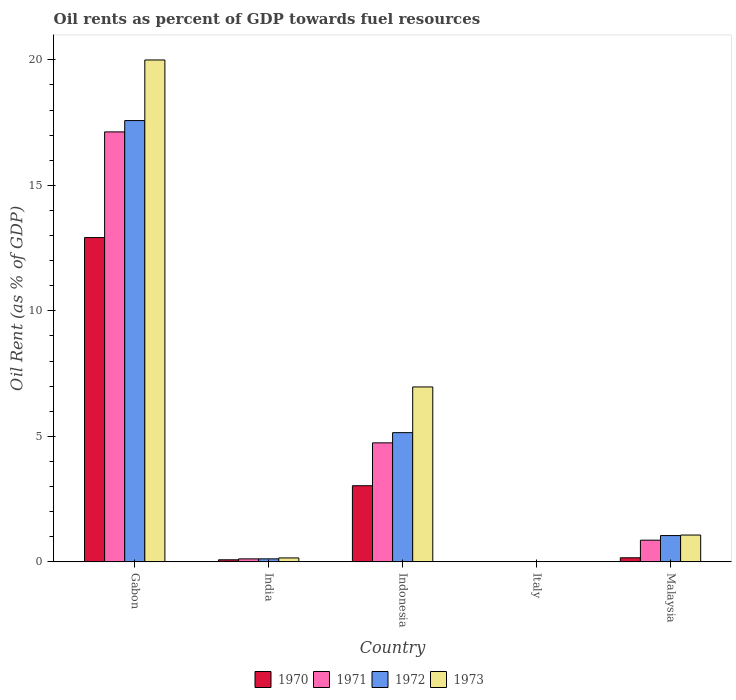How many groups of bars are there?
Give a very brief answer. 5. What is the label of the 5th group of bars from the left?
Ensure brevity in your answer.  Malaysia. What is the oil rent in 1970 in Gabon?
Keep it short and to the point. 12.92. Across all countries, what is the maximum oil rent in 1972?
Offer a very short reply. 17.58. Across all countries, what is the minimum oil rent in 1970?
Give a very brief answer. 0.01. In which country was the oil rent in 1971 maximum?
Your answer should be compact. Gabon. In which country was the oil rent in 1970 minimum?
Your answer should be compact. Italy. What is the total oil rent in 1970 in the graph?
Your answer should be compact. 16.21. What is the difference between the oil rent in 1970 in India and that in Italy?
Your answer should be very brief. 0.07. What is the difference between the oil rent in 1971 in Indonesia and the oil rent in 1970 in Gabon?
Ensure brevity in your answer.  -8.18. What is the average oil rent in 1970 per country?
Provide a short and direct response. 3.24. What is the difference between the oil rent of/in 1973 and oil rent of/in 1971 in India?
Give a very brief answer. 0.04. What is the ratio of the oil rent in 1970 in Gabon to that in Italy?
Your answer should be compact. 1310.76. What is the difference between the highest and the second highest oil rent in 1972?
Your answer should be very brief. 12.43. What is the difference between the highest and the lowest oil rent in 1970?
Make the answer very short. 12.91. In how many countries, is the oil rent in 1973 greater than the average oil rent in 1973 taken over all countries?
Give a very brief answer. 2. Is the sum of the oil rent in 1970 in Gabon and Malaysia greater than the maximum oil rent in 1973 across all countries?
Offer a very short reply. No. How many countries are there in the graph?
Your answer should be compact. 5. What is the difference between two consecutive major ticks on the Y-axis?
Your response must be concise. 5. Are the values on the major ticks of Y-axis written in scientific E-notation?
Your response must be concise. No. Where does the legend appear in the graph?
Make the answer very short. Bottom center. What is the title of the graph?
Provide a succinct answer. Oil rents as percent of GDP towards fuel resources. Does "2004" appear as one of the legend labels in the graph?
Your answer should be compact. No. What is the label or title of the X-axis?
Your answer should be compact. Country. What is the label or title of the Y-axis?
Provide a succinct answer. Oil Rent (as % of GDP). What is the Oil Rent (as % of GDP) in 1970 in Gabon?
Ensure brevity in your answer.  12.92. What is the Oil Rent (as % of GDP) of 1971 in Gabon?
Your answer should be very brief. 17.13. What is the Oil Rent (as % of GDP) of 1972 in Gabon?
Provide a succinct answer. 17.58. What is the Oil Rent (as % of GDP) of 1973 in Gabon?
Provide a short and direct response. 19.99. What is the Oil Rent (as % of GDP) of 1970 in India?
Provide a succinct answer. 0.08. What is the Oil Rent (as % of GDP) in 1971 in India?
Offer a terse response. 0.12. What is the Oil Rent (as % of GDP) in 1972 in India?
Offer a terse response. 0.12. What is the Oil Rent (as % of GDP) of 1973 in India?
Give a very brief answer. 0.16. What is the Oil Rent (as % of GDP) in 1970 in Indonesia?
Provide a succinct answer. 3.03. What is the Oil Rent (as % of GDP) of 1971 in Indonesia?
Your response must be concise. 4.74. What is the Oil Rent (as % of GDP) in 1972 in Indonesia?
Provide a short and direct response. 5.15. What is the Oil Rent (as % of GDP) of 1973 in Indonesia?
Your answer should be very brief. 6.97. What is the Oil Rent (as % of GDP) of 1970 in Italy?
Give a very brief answer. 0.01. What is the Oil Rent (as % of GDP) in 1971 in Italy?
Offer a terse response. 0.01. What is the Oil Rent (as % of GDP) of 1972 in Italy?
Offer a terse response. 0.01. What is the Oil Rent (as % of GDP) of 1973 in Italy?
Offer a terse response. 0.01. What is the Oil Rent (as % of GDP) in 1970 in Malaysia?
Make the answer very short. 0.16. What is the Oil Rent (as % of GDP) of 1971 in Malaysia?
Provide a succinct answer. 0.86. What is the Oil Rent (as % of GDP) of 1972 in Malaysia?
Offer a terse response. 1.05. What is the Oil Rent (as % of GDP) in 1973 in Malaysia?
Your response must be concise. 1.07. Across all countries, what is the maximum Oil Rent (as % of GDP) of 1970?
Provide a short and direct response. 12.92. Across all countries, what is the maximum Oil Rent (as % of GDP) in 1971?
Ensure brevity in your answer.  17.13. Across all countries, what is the maximum Oil Rent (as % of GDP) of 1972?
Give a very brief answer. 17.58. Across all countries, what is the maximum Oil Rent (as % of GDP) in 1973?
Your answer should be compact. 19.99. Across all countries, what is the minimum Oil Rent (as % of GDP) of 1970?
Offer a very short reply. 0.01. Across all countries, what is the minimum Oil Rent (as % of GDP) in 1971?
Provide a succinct answer. 0.01. Across all countries, what is the minimum Oil Rent (as % of GDP) of 1972?
Ensure brevity in your answer.  0.01. Across all countries, what is the minimum Oil Rent (as % of GDP) in 1973?
Ensure brevity in your answer.  0.01. What is the total Oil Rent (as % of GDP) of 1970 in the graph?
Your answer should be very brief. 16.21. What is the total Oil Rent (as % of GDP) in 1971 in the graph?
Provide a short and direct response. 22.87. What is the total Oil Rent (as % of GDP) of 1972 in the graph?
Keep it short and to the point. 23.91. What is the total Oil Rent (as % of GDP) of 1973 in the graph?
Keep it short and to the point. 28.2. What is the difference between the Oil Rent (as % of GDP) of 1970 in Gabon and that in India?
Your answer should be compact. 12.84. What is the difference between the Oil Rent (as % of GDP) of 1971 in Gabon and that in India?
Your answer should be very brief. 17.01. What is the difference between the Oil Rent (as % of GDP) in 1972 in Gabon and that in India?
Give a very brief answer. 17.46. What is the difference between the Oil Rent (as % of GDP) in 1973 in Gabon and that in India?
Ensure brevity in your answer.  19.84. What is the difference between the Oil Rent (as % of GDP) in 1970 in Gabon and that in Indonesia?
Keep it short and to the point. 9.88. What is the difference between the Oil Rent (as % of GDP) in 1971 in Gabon and that in Indonesia?
Make the answer very short. 12.39. What is the difference between the Oil Rent (as % of GDP) in 1972 in Gabon and that in Indonesia?
Provide a succinct answer. 12.43. What is the difference between the Oil Rent (as % of GDP) in 1973 in Gabon and that in Indonesia?
Provide a short and direct response. 13.03. What is the difference between the Oil Rent (as % of GDP) in 1970 in Gabon and that in Italy?
Provide a short and direct response. 12.91. What is the difference between the Oil Rent (as % of GDP) of 1971 in Gabon and that in Italy?
Offer a very short reply. 17.12. What is the difference between the Oil Rent (as % of GDP) of 1972 in Gabon and that in Italy?
Your answer should be compact. 17.57. What is the difference between the Oil Rent (as % of GDP) of 1973 in Gabon and that in Italy?
Your response must be concise. 19.98. What is the difference between the Oil Rent (as % of GDP) in 1970 in Gabon and that in Malaysia?
Your response must be concise. 12.76. What is the difference between the Oil Rent (as % of GDP) in 1971 in Gabon and that in Malaysia?
Your answer should be very brief. 16.26. What is the difference between the Oil Rent (as % of GDP) in 1972 in Gabon and that in Malaysia?
Keep it short and to the point. 16.53. What is the difference between the Oil Rent (as % of GDP) in 1973 in Gabon and that in Malaysia?
Offer a very short reply. 18.92. What is the difference between the Oil Rent (as % of GDP) of 1970 in India and that in Indonesia?
Make the answer very short. -2.95. What is the difference between the Oil Rent (as % of GDP) in 1971 in India and that in Indonesia?
Give a very brief answer. -4.62. What is the difference between the Oil Rent (as % of GDP) of 1972 in India and that in Indonesia?
Ensure brevity in your answer.  -5.03. What is the difference between the Oil Rent (as % of GDP) in 1973 in India and that in Indonesia?
Keep it short and to the point. -6.81. What is the difference between the Oil Rent (as % of GDP) in 1970 in India and that in Italy?
Your answer should be very brief. 0.07. What is the difference between the Oil Rent (as % of GDP) in 1971 in India and that in Italy?
Your response must be concise. 0.11. What is the difference between the Oil Rent (as % of GDP) in 1972 in India and that in Italy?
Your response must be concise. 0.11. What is the difference between the Oil Rent (as % of GDP) in 1973 in India and that in Italy?
Offer a very short reply. 0.15. What is the difference between the Oil Rent (as % of GDP) of 1970 in India and that in Malaysia?
Offer a terse response. -0.08. What is the difference between the Oil Rent (as % of GDP) in 1971 in India and that in Malaysia?
Offer a very short reply. -0.74. What is the difference between the Oil Rent (as % of GDP) in 1972 in India and that in Malaysia?
Your response must be concise. -0.93. What is the difference between the Oil Rent (as % of GDP) in 1973 in India and that in Malaysia?
Your answer should be compact. -0.91. What is the difference between the Oil Rent (as % of GDP) in 1970 in Indonesia and that in Italy?
Make the answer very short. 3.02. What is the difference between the Oil Rent (as % of GDP) of 1971 in Indonesia and that in Italy?
Ensure brevity in your answer.  4.73. What is the difference between the Oil Rent (as % of GDP) of 1972 in Indonesia and that in Italy?
Your response must be concise. 5.14. What is the difference between the Oil Rent (as % of GDP) in 1973 in Indonesia and that in Italy?
Offer a very short reply. 6.96. What is the difference between the Oil Rent (as % of GDP) in 1970 in Indonesia and that in Malaysia?
Keep it short and to the point. 2.87. What is the difference between the Oil Rent (as % of GDP) of 1971 in Indonesia and that in Malaysia?
Offer a very short reply. 3.88. What is the difference between the Oil Rent (as % of GDP) in 1972 in Indonesia and that in Malaysia?
Your response must be concise. 4.1. What is the difference between the Oil Rent (as % of GDP) in 1973 in Indonesia and that in Malaysia?
Ensure brevity in your answer.  5.9. What is the difference between the Oil Rent (as % of GDP) of 1970 in Italy and that in Malaysia?
Provide a short and direct response. -0.15. What is the difference between the Oil Rent (as % of GDP) of 1971 in Italy and that in Malaysia?
Your answer should be compact. -0.85. What is the difference between the Oil Rent (as % of GDP) of 1972 in Italy and that in Malaysia?
Your answer should be very brief. -1.04. What is the difference between the Oil Rent (as % of GDP) of 1973 in Italy and that in Malaysia?
Keep it short and to the point. -1.06. What is the difference between the Oil Rent (as % of GDP) of 1970 in Gabon and the Oil Rent (as % of GDP) of 1971 in India?
Ensure brevity in your answer.  12.8. What is the difference between the Oil Rent (as % of GDP) of 1970 in Gabon and the Oil Rent (as % of GDP) of 1972 in India?
Ensure brevity in your answer.  12.8. What is the difference between the Oil Rent (as % of GDP) of 1970 in Gabon and the Oil Rent (as % of GDP) of 1973 in India?
Keep it short and to the point. 12.76. What is the difference between the Oil Rent (as % of GDP) in 1971 in Gabon and the Oil Rent (as % of GDP) in 1972 in India?
Your answer should be compact. 17.01. What is the difference between the Oil Rent (as % of GDP) in 1971 in Gabon and the Oil Rent (as % of GDP) in 1973 in India?
Your response must be concise. 16.97. What is the difference between the Oil Rent (as % of GDP) in 1972 in Gabon and the Oil Rent (as % of GDP) in 1973 in India?
Ensure brevity in your answer.  17.42. What is the difference between the Oil Rent (as % of GDP) in 1970 in Gabon and the Oil Rent (as % of GDP) in 1971 in Indonesia?
Your answer should be very brief. 8.18. What is the difference between the Oil Rent (as % of GDP) of 1970 in Gabon and the Oil Rent (as % of GDP) of 1972 in Indonesia?
Your answer should be compact. 7.77. What is the difference between the Oil Rent (as % of GDP) in 1970 in Gabon and the Oil Rent (as % of GDP) in 1973 in Indonesia?
Offer a terse response. 5.95. What is the difference between the Oil Rent (as % of GDP) in 1971 in Gabon and the Oil Rent (as % of GDP) in 1972 in Indonesia?
Your response must be concise. 11.98. What is the difference between the Oil Rent (as % of GDP) in 1971 in Gabon and the Oil Rent (as % of GDP) in 1973 in Indonesia?
Offer a very short reply. 10.16. What is the difference between the Oil Rent (as % of GDP) in 1972 in Gabon and the Oil Rent (as % of GDP) in 1973 in Indonesia?
Keep it short and to the point. 10.61. What is the difference between the Oil Rent (as % of GDP) of 1970 in Gabon and the Oil Rent (as % of GDP) of 1971 in Italy?
Offer a very short reply. 12.91. What is the difference between the Oil Rent (as % of GDP) in 1970 in Gabon and the Oil Rent (as % of GDP) in 1972 in Italy?
Offer a terse response. 12.91. What is the difference between the Oil Rent (as % of GDP) in 1970 in Gabon and the Oil Rent (as % of GDP) in 1973 in Italy?
Make the answer very short. 12.91. What is the difference between the Oil Rent (as % of GDP) of 1971 in Gabon and the Oil Rent (as % of GDP) of 1972 in Italy?
Offer a very short reply. 17.12. What is the difference between the Oil Rent (as % of GDP) of 1971 in Gabon and the Oil Rent (as % of GDP) of 1973 in Italy?
Your answer should be compact. 17.12. What is the difference between the Oil Rent (as % of GDP) of 1972 in Gabon and the Oil Rent (as % of GDP) of 1973 in Italy?
Your answer should be compact. 17.57. What is the difference between the Oil Rent (as % of GDP) of 1970 in Gabon and the Oil Rent (as % of GDP) of 1971 in Malaysia?
Ensure brevity in your answer.  12.05. What is the difference between the Oil Rent (as % of GDP) in 1970 in Gabon and the Oil Rent (as % of GDP) in 1972 in Malaysia?
Keep it short and to the point. 11.87. What is the difference between the Oil Rent (as % of GDP) in 1970 in Gabon and the Oil Rent (as % of GDP) in 1973 in Malaysia?
Make the answer very short. 11.85. What is the difference between the Oil Rent (as % of GDP) in 1971 in Gabon and the Oil Rent (as % of GDP) in 1972 in Malaysia?
Keep it short and to the point. 16.08. What is the difference between the Oil Rent (as % of GDP) in 1971 in Gabon and the Oil Rent (as % of GDP) in 1973 in Malaysia?
Provide a succinct answer. 16.06. What is the difference between the Oil Rent (as % of GDP) of 1972 in Gabon and the Oil Rent (as % of GDP) of 1973 in Malaysia?
Give a very brief answer. 16.51. What is the difference between the Oil Rent (as % of GDP) in 1970 in India and the Oil Rent (as % of GDP) in 1971 in Indonesia?
Make the answer very short. -4.66. What is the difference between the Oil Rent (as % of GDP) of 1970 in India and the Oil Rent (as % of GDP) of 1972 in Indonesia?
Your response must be concise. -5.07. What is the difference between the Oil Rent (as % of GDP) in 1970 in India and the Oil Rent (as % of GDP) in 1973 in Indonesia?
Your response must be concise. -6.89. What is the difference between the Oil Rent (as % of GDP) in 1971 in India and the Oil Rent (as % of GDP) in 1972 in Indonesia?
Your response must be concise. -5.03. What is the difference between the Oil Rent (as % of GDP) in 1971 in India and the Oil Rent (as % of GDP) in 1973 in Indonesia?
Your answer should be very brief. -6.85. What is the difference between the Oil Rent (as % of GDP) in 1972 in India and the Oil Rent (as % of GDP) in 1973 in Indonesia?
Offer a very short reply. -6.85. What is the difference between the Oil Rent (as % of GDP) in 1970 in India and the Oil Rent (as % of GDP) in 1971 in Italy?
Your answer should be compact. 0.07. What is the difference between the Oil Rent (as % of GDP) in 1970 in India and the Oil Rent (as % of GDP) in 1972 in Italy?
Provide a succinct answer. 0.07. What is the difference between the Oil Rent (as % of GDP) in 1970 in India and the Oil Rent (as % of GDP) in 1973 in Italy?
Provide a short and direct response. 0.07. What is the difference between the Oil Rent (as % of GDP) of 1971 in India and the Oil Rent (as % of GDP) of 1972 in Italy?
Ensure brevity in your answer.  0.11. What is the difference between the Oil Rent (as % of GDP) of 1971 in India and the Oil Rent (as % of GDP) of 1973 in Italy?
Give a very brief answer. 0.11. What is the difference between the Oil Rent (as % of GDP) in 1972 in India and the Oil Rent (as % of GDP) in 1973 in Italy?
Provide a short and direct response. 0.11. What is the difference between the Oil Rent (as % of GDP) of 1970 in India and the Oil Rent (as % of GDP) of 1971 in Malaysia?
Ensure brevity in your answer.  -0.78. What is the difference between the Oil Rent (as % of GDP) of 1970 in India and the Oil Rent (as % of GDP) of 1972 in Malaysia?
Your response must be concise. -0.97. What is the difference between the Oil Rent (as % of GDP) of 1970 in India and the Oil Rent (as % of GDP) of 1973 in Malaysia?
Offer a terse response. -0.99. What is the difference between the Oil Rent (as % of GDP) in 1971 in India and the Oil Rent (as % of GDP) in 1972 in Malaysia?
Make the answer very short. -0.93. What is the difference between the Oil Rent (as % of GDP) of 1971 in India and the Oil Rent (as % of GDP) of 1973 in Malaysia?
Your answer should be compact. -0.95. What is the difference between the Oil Rent (as % of GDP) of 1972 in India and the Oil Rent (as % of GDP) of 1973 in Malaysia?
Ensure brevity in your answer.  -0.95. What is the difference between the Oil Rent (as % of GDP) of 1970 in Indonesia and the Oil Rent (as % of GDP) of 1971 in Italy?
Give a very brief answer. 3.02. What is the difference between the Oil Rent (as % of GDP) in 1970 in Indonesia and the Oil Rent (as % of GDP) in 1972 in Italy?
Your answer should be compact. 3.02. What is the difference between the Oil Rent (as % of GDP) in 1970 in Indonesia and the Oil Rent (as % of GDP) in 1973 in Italy?
Offer a terse response. 3.02. What is the difference between the Oil Rent (as % of GDP) of 1971 in Indonesia and the Oil Rent (as % of GDP) of 1972 in Italy?
Offer a terse response. 4.73. What is the difference between the Oil Rent (as % of GDP) of 1971 in Indonesia and the Oil Rent (as % of GDP) of 1973 in Italy?
Your answer should be very brief. 4.73. What is the difference between the Oil Rent (as % of GDP) of 1972 in Indonesia and the Oil Rent (as % of GDP) of 1973 in Italy?
Give a very brief answer. 5.14. What is the difference between the Oil Rent (as % of GDP) of 1970 in Indonesia and the Oil Rent (as % of GDP) of 1971 in Malaysia?
Your answer should be compact. 2.17. What is the difference between the Oil Rent (as % of GDP) in 1970 in Indonesia and the Oil Rent (as % of GDP) in 1972 in Malaysia?
Offer a very short reply. 1.99. What is the difference between the Oil Rent (as % of GDP) in 1970 in Indonesia and the Oil Rent (as % of GDP) in 1973 in Malaysia?
Make the answer very short. 1.96. What is the difference between the Oil Rent (as % of GDP) in 1971 in Indonesia and the Oil Rent (as % of GDP) in 1972 in Malaysia?
Offer a terse response. 3.69. What is the difference between the Oil Rent (as % of GDP) in 1971 in Indonesia and the Oil Rent (as % of GDP) in 1973 in Malaysia?
Keep it short and to the point. 3.67. What is the difference between the Oil Rent (as % of GDP) of 1972 in Indonesia and the Oil Rent (as % of GDP) of 1973 in Malaysia?
Give a very brief answer. 4.08. What is the difference between the Oil Rent (as % of GDP) of 1970 in Italy and the Oil Rent (as % of GDP) of 1971 in Malaysia?
Your answer should be very brief. -0.85. What is the difference between the Oil Rent (as % of GDP) of 1970 in Italy and the Oil Rent (as % of GDP) of 1972 in Malaysia?
Offer a terse response. -1.04. What is the difference between the Oil Rent (as % of GDP) in 1970 in Italy and the Oil Rent (as % of GDP) in 1973 in Malaysia?
Give a very brief answer. -1.06. What is the difference between the Oil Rent (as % of GDP) of 1971 in Italy and the Oil Rent (as % of GDP) of 1972 in Malaysia?
Provide a succinct answer. -1.04. What is the difference between the Oil Rent (as % of GDP) of 1971 in Italy and the Oil Rent (as % of GDP) of 1973 in Malaysia?
Offer a very short reply. -1.06. What is the difference between the Oil Rent (as % of GDP) in 1972 in Italy and the Oil Rent (as % of GDP) in 1973 in Malaysia?
Make the answer very short. -1.06. What is the average Oil Rent (as % of GDP) of 1970 per country?
Keep it short and to the point. 3.24. What is the average Oil Rent (as % of GDP) of 1971 per country?
Offer a very short reply. 4.57. What is the average Oil Rent (as % of GDP) in 1972 per country?
Make the answer very short. 4.78. What is the average Oil Rent (as % of GDP) in 1973 per country?
Make the answer very short. 5.64. What is the difference between the Oil Rent (as % of GDP) of 1970 and Oil Rent (as % of GDP) of 1971 in Gabon?
Provide a short and direct response. -4.21. What is the difference between the Oil Rent (as % of GDP) in 1970 and Oil Rent (as % of GDP) in 1972 in Gabon?
Offer a terse response. -4.66. What is the difference between the Oil Rent (as % of GDP) of 1970 and Oil Rent (as % of GDP) of 1973 in Gabon?
Offer a very short reply. -7.08. What is the difference between the Oil Rent (as % of GDP) of 1971 and Oil Rent (as % of GDP) of 1972 in Gabon?
Offer a very short reply. -0.45. What is the difference between the Oil Rent (as % of GDP) of 1971 and Oil Rent (as % of GDP) of 1973 in Gabon?
Ensure brevity in your answer.  -2.87. What is the difference between the Oil Rent (as % of GDP) of 1972 and Oil Rent (as % of GDP) of 1973 in Gabon?
Your answer should be compact. -2.41. What is the difference between the Oil Rent (as % of GDP) in 1970 and Oil Rent (as % of GDP) in 1971 in India?
Your response must be concise. -0.04. What is the difference between the Oil Rent (as % of GDP) of 1970 and Oil Rent (as % of GDP) of 1972 in India?
Your answer should be very brief. -0.04. What is the difference between the Oil Rent (as % of GDP) of 1970 and Oil Rent (as % of GDP) of 1973 in India?
Provide a short and direct response. -0.07. What is the difference between the Oil Rent (as % of GDP) of 1971 and Oil Rent (as % of GDP) of 1972 in India?
Keep it short and to the point. -0. What is the difference between the Oil Rent (as % of GDP) of 1971 and Oil Rent (as % of GDP) of 1973 in India?
Offer a very short reply. -0.04. What is the difference between the Oil Rent (as % of GDP) of 1972 and Oil Rent (as % of GDP) of 1973 in India?
Your response must be concise. -0.04. What is the difference between the Oil Rent (as % of GDP) of 1970 and Oil Rent (as % of GDP) of 1971 in Indonesia?
Provide a short and direct response. -1.71. What is the difference between the Oil Rent (as % of GDP) of 1970 and Oil Rent (as % of GDP) of 1972 in Indonesia?
Give a very brief answer. -2.11. What is the difference between the Oil Rent (as % of GDP) of 1970 and Oil Rent (as % of GDP) of 1973 in Indonesia?
Your answer should be very brief. -3.93. What is the difference between the Oil Rent (as % of GDP) of 1971 and Oil Rent (as % of GDP) of 1972 in Indonesia?
Your answer should be very brief. -0.41. What is the difference between the Oil Rent (as % of GDP) in 1971 and Oil Rent (as % of GDP) in 1973 in Indonesia?
Your response must be concise. -2.23. What is the difference between the Oil Rent (as % of GDP) of 1972 and Oil Rent (as % of GDP) of 1973 in Indonesia?
Give a very brief answer. -1.82. What is the difference between the Oil Rent (as % of GDP) in 1970 and Oil Rent (as % of GDP) in 1971 in Italy?
Your answer should be very brief. -0. What is the difference between the Oil Rent (as % of GDP) of 1970 and Oil Rent (as % of GDP) of 1972 in Italy?
Offer a very short reply. 0. What is the difference between the Oil Rent (as % of GDP) in 1970 and Oil Rent (as % of GDP) in 1973 in Italy?
Your answer should be very brief. -0. What is the difference between the Oil Rent (as % of GDP) in 1971 and Oil Rent (as % of GDP) in 1972 in Italy?
Keep it short and to the point. 0. What is the difference between the Oil Rent (as % of GDP) of 1972 and Oil Rent (as % of GDP) of 1973 in Italy?
Offer a terse response. -0. What is the difference between the Oil Rent (as % of GDP) of 1970 and Oil Rent (as % of GDP) of 1971 in Malaysia?
Ensure brevity in your answer.  -0.7. What is the difference between the Oil Rent (as % of GDP) of 1970 and Oil Rent (as % of GDP) of 1972 in Malaysia?
Make the answer very short. -0.89. What is the difference between the Oil Rent (as % of GDP) in 1970 and Oil Rent (as % of GDP) in 1973 in Malaysia?
Make the answer very short. -0.91. What is the difference between the Oil Rent (as % of GDP) of 1971 and Oil Rent (as % of GDP) of 1972 in Malaysia?
Your answer should be very brief. -0.18. What is the difference between the Oil Rent (as % of GDP) of 1971 and Oil Rent (as % of GDP) of 1973 in Malaysia?
Ensure brevity in your answer.  -0.2. What is the difference between the Oil Rent (as % of GDP) in 1972 and Oil Rent (as % of GDP) in 1973 in Malaysia?
Provide a succinct answer. -0.02. What is the ratio of the Oil Rent (as % of GDP) of 1970 in Gabon to that in India?
Your answer should be very brief. 156.62. What is the ratio of the Oil Rent (as % of GDP) in 1971 in Gabon to that in India?
Offer a very short reply. 142.99. What is the ratio of the Oil Rent (as % of GDP) of 1972 in Gabon to that in India?
Keep it short and to the point. 146.29. What is the ratio of the Oil Rent (as % of GDP) in 1973 in Gabon to that in India?
Provide a succinct answer. 127.16. What is the ratio of the Oil Rent (as % of GDP) of 1970 in Gabon to that in Indonesia?
Keep it short and to the point. 4.26. What is the ratio of the Oil Rent (as % of GDP) of 1971 in Gabon to that in Indonesia?
Provide a short and direct response. 3.61. What is the ratio of the Oil Rent (as % of GDP) in 1972 in Gabon to that in Indonesia?
Offer a very short reply. 3.41. What is the ratio of the Oil Rent (as % of GDP) of 1973 in Gabon to that in Indonesia?
Provide a short and direct response. 2.87. What is the ratio of the Oil Rent (as % of GDP) of 1970 in Gabon to that in Italy?
Keep it short and to the point. 1310.76. What is the ratio of the Oil Rent (as % of GDP) in 1971 in Gabon to that in Italy?
Ensure brevity in your answer.  1461.71. What is the ratio of the Oil Rent (as % of GDP) in 1972 in Gabon to that in Italy?
Your answer should be very brief. 1889.75. What is the ratio of the Oil Rent (as % of GDP) in 1973 in Gabon to that in Italy?
Give a very brief answer. 1784.8. What is the ratio of the Oil Rent (as % of GDP) of 1970 in Gabon to that in Malaysia?
Provide a succinct answer. 79.24. What is the ratio of the Oil Rent (as % of GDP) in 1971 in Gabon to that in Malaysia?
Your answer should be compact. 19.81. What is the ratio of the Oil Rent (as % of GDP) of 1972 in Gabon to that in Malaysia?
Offer a terse response. 16.77. What is the ratio of the Oil Rent (as % of GDP) in 1973 in Gabon to that in Malaysia?
Your answer should be very brief. 18.71. What is the ratio of the Oil Rent (as % of GDP) in 1970 in India to that in Indonesia?
Your response must be concise. 0.03. What is the ratio of the Oil Rent (as % of GDP) of 1971 in India to that in Indonesia?
Provide a short and direct response. 0.03. What is the ratio of the Oil Rent (as % of GDP) in 1972 in India to that in Indonesia?
Provide a short and direct response. 0.02. What is the ratio of the Oil Rent (as % of GDP) of 1973 in India to that in Indonesia?
Give a very brief answer. 0.02. What is the ratio of the Oil Rent (as % of GDP) of 1970 in India to that in Italy?
Provide a succinct answer. 8.37. What is the ratio of the Oil Rent (as % of GDP) in 1971 in India to that in Italy?
Offer a very short reply. 10.22. What is the ratio of the Oil Rent (as % of GDP) of 1972 in India to that in Italy?
Offer a very short reply. 12.92. What is the ratio of the Oil Rent (as % of GDP) in 1973 in India to that in Italy?
Keep it short and to the point. 14.04. What is the ratio of the Oil Rent (as % of GDP) in 1970 in India to that in Malaysia?
Keep it short and to the point. 0.51. What is the ratio of the Oil Rent (as % of GDP) in 1971 in India to that in Malaysia?
Give a very brief answer. 0.14. What is the ratio of the Oil Rent (as % of GDP) of 1972 in India to that in Malaysia?
Keep it short and to the point. 0.11. What is the ratio of the Oil Rent (as % of GDP) in 1973 in India to that in Malaysia?
Your response must be concise. 0.15. What is the ratio of the Oil Rent (as % of GDP) in 1970 in Indonesia to that in Italy?
Keep it short and to the point. 307.81. What is the ratio of the Oil Rent (as % of GDP) in 1971 in Indonesia to that in Italy?
Make the answer very short. 404.61. What is the ratio of the Oil Rent (as % of GDP) of 1972 in Indonesia to that in Italy?
Ensure brevity in your answer.  553.4. What is the ratio of the Oil Rent (as % of GDP) of 1973 in Indonesia to that in Italy?
Keep it short and to the point. 622.04. What is the ratio of the Oil Rent (as % of GDP) of 1970 in Indonesia to that in Malaysia?
Your answer should be compact. 18.61. What is the ratio of the Oil Rent (as % of GDP) in 1971 in Indonesia to that in Malaysia?
Offer a very short reply. 5.48. What is the ratio of the Oil Rent (as % of GDP) of 1972 in Indonesia to that in Malaysia?
Your response must be concise. 4.91. What is the ratio of the Oil Rent (as % of GDP) in 1973 in Indonesia to that in Malaysia?
Your answer should be compact. 6.52. What is the ratio of the Oil Rent (as % of GDP) in 1970 in Italy to that in Malaysia?
Provide a succinct answer. 0.06. What is the ratio of the Oil Rent (as % of GDP) of 1971 in Italy to that in Malaysia?
Provide a short and direct response. 0.01. What is the ratio of the Oil Rent (as % of GDP) in 1972 in Italy to that in Malaysia?
Offer a terse response. 0.01. What is the ratio of the Oil Rent (as % of GDP) in 1973 in Italy to that in Malaysia?
Offer a very short reply. 0.01. What is the difference between the highest and the second highest Oil Rent (as % of GDP) in 1970?
Your answer should be compact. 9.88. What is the difference between the highest and the second highest Oil Rent (as % of GDP) in 1971?
Offer a very short reply. 12.39. What is the difference between the highest and the second highest Oil Rent (as % of GDP) in 1972?
Provide a short and direct response. 12.43. What is the difference between the highest and the second highest Oil Rent (as % of GDP) in 1973?
Your response must be concise. 13.03. What is the difference between the highest and the lowest Oil Rent (as % of GDP) in 1970?
Your response must be concise. 12.91. What is the difference between the highest and the lowest Oil Rent (as % of GDP) of 1971?
Your answer should be compact. 17.12. What is the difference between the highest and the lowest Oil Rent (as % of GDP) in 1972?
Your answer should be very brief. 17.57. What is the difference between the highest and the lowest Oil Rent (as % of GDP) of 1973?
Give a very brief answer. 19.98. 